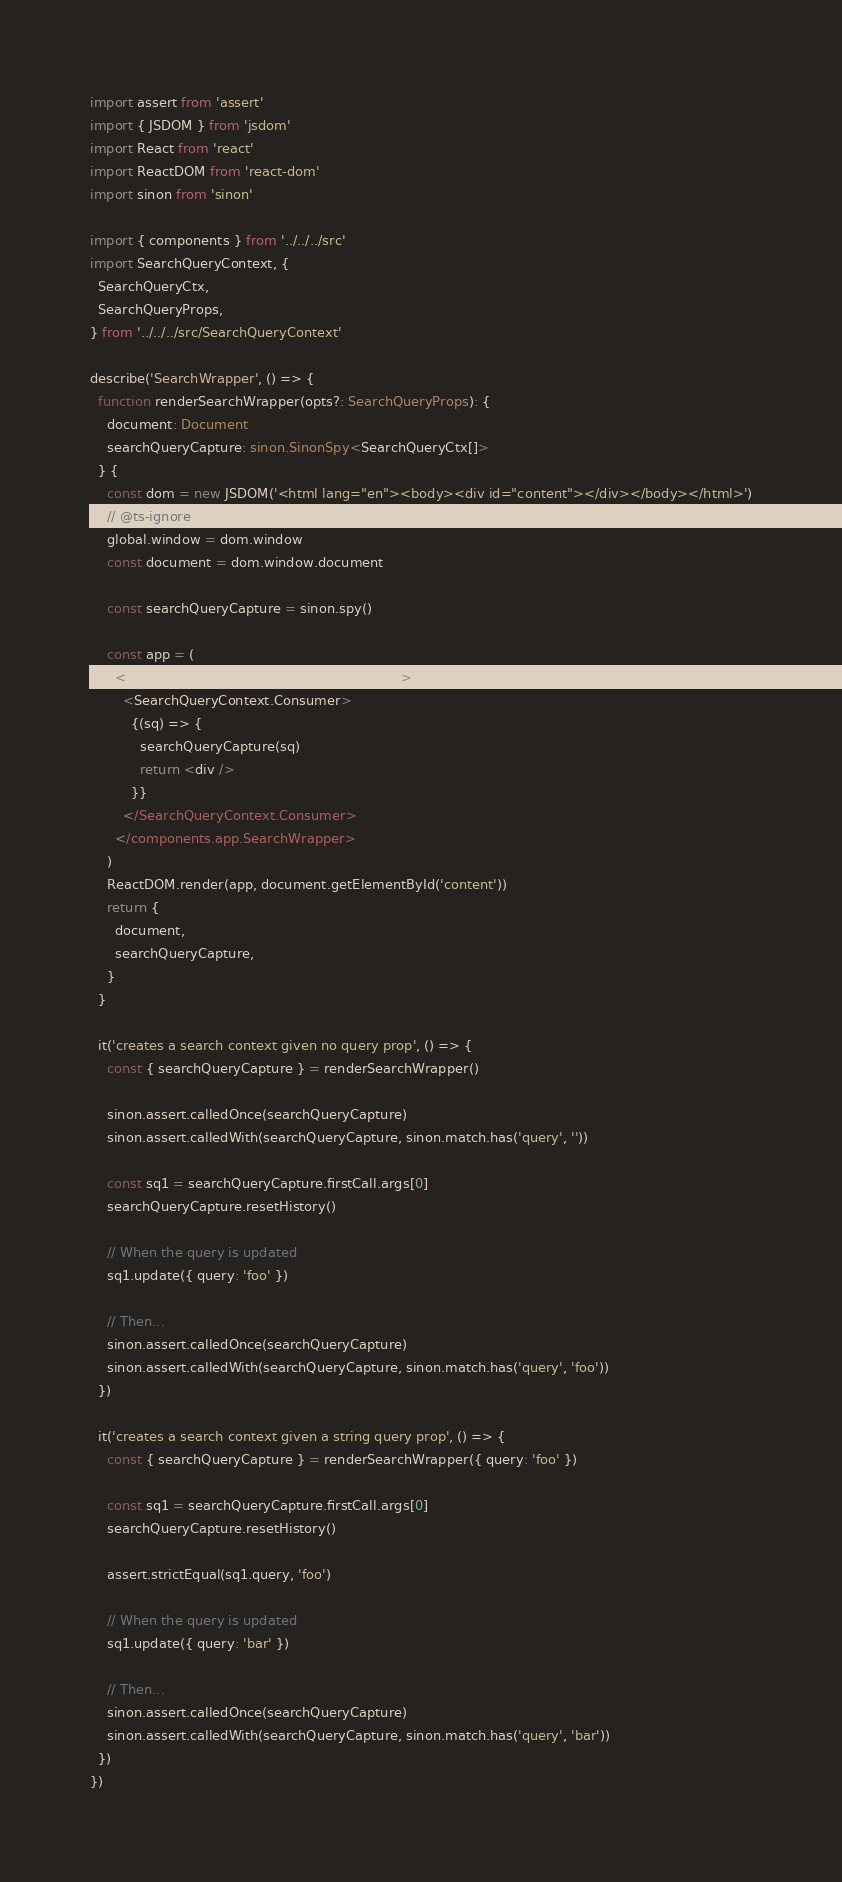<code> <loc_0><loc_0><loc_500><loc_500><_TypeScript_>import assert from 'assert'
import { JSDOM } from 'jsdom'
import React from 'react'
import ReactDOM from 'react-dom'
import sinon from 'sinon'

import { components } from '../../../src'
import SearchQueryContext, {
  SearchQueryCtx,
  SearchQueryProps,
} from '../../../src/SearchQueryContext'

describe('SearchWrapper', () => {
  function renderSearchWrapper(opts?: SearchQueryProps): {
    document: Document
    searchQueryCapture: sinon.SinonSpy<SearchQueryCtx[]>
  } {
    const dom = new JSDOM('<html lang="en"><body><div id="content"></div></body></html>')
    // @ts-ignore
    global.window = dom.window
    const document = dom.window.document

    const searchQueryCapture = sinon.spy()

    const app = (
      <components.app.SearchWrapper {...opts}>
        <SearchQueryContext.Consumer>
          {(sq) => {
            searchQueryCapture(sq)
            return <div />
          }}
        </SearchQueryContext.Consumer>
      </components.app.SearchWrapper>
    )
    ReactDOM.render(app, document.getElementById('content'))
    return {
      document,
      searchQueryCapture,
    }
  }

  it('creates a search context given no query prop', () => {
    const { searchQueryCapture } = renderSearchWrapper()

    sinon.assert.calledOnce(searchQueryCapture)
    sinon.assert.calledWith(searchQueryCapture, sinon.match.has('query', ''))

    const sq1 = searchQueryCapture.firstCall.args[0]
    searchQueryCapture.resetHistory()

    // When the query is updated
    sq1.update({ query: 'foo' })

    // Then...
    sinon.assert.calledOnce(searchQueryCapture)
    sinon.assert.calledWith(searchQueryCapture, sinon.match.has('query', 'foo'))
  })

  it('creates a search context given a string query prop', () => {
    const { searchQueryCapture } = renderSearchWrapper({ query: 'foo' })

    const sq1 = searchQueryCapture.firstCall.args[0]
    searchQueryCapture.resetHistory()

    assert.strictEqual(sq1.query, 'foo')

    // When the query is updated
    sq1.update({ query: 'bar' })

    // Then...
    sinon.assert.calledOnce(searchQueryCapture)
    sinon.assert.calledWith(searchQueryCapture, sinon.match.has('query', 'bar'))
  })
})
</code> 